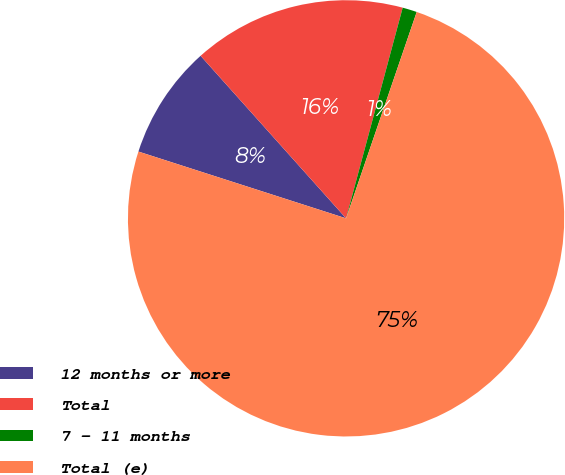Convert chart. <chart><loc_0><loc_0><loc_500><loc_500><pie_chart><fcel>12 months or more<fcel>Total<fcel>7 - 11 months<fcel>Total (e)<nl><fcel>8.43%<fcel>15.8%<fcel>1.07%<fcel>74.71%<nl></chart> 